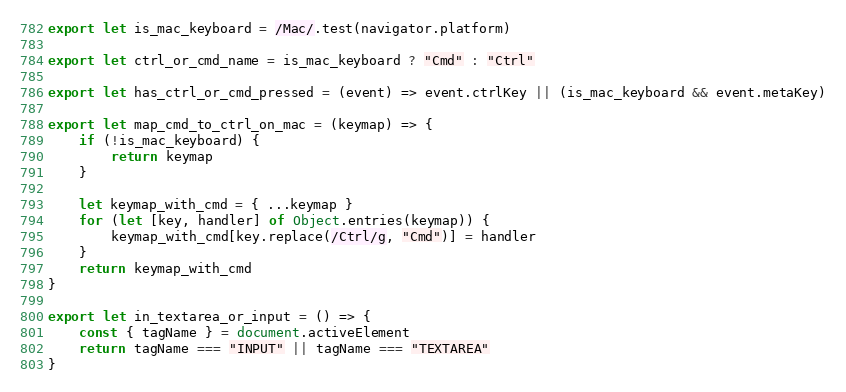Convert code to text. <code><loc_0><loc_0><loc_500><loc_500><_JavaScript_>export let is_mac_keyboard = /Mac/.test(navigator.platform)

export let ctrl_or_cmd_name = is_mac_keyboard ? "Cmd" : "Ctrl"

export let has_ctrl_or_cmd_pressed = (event) => event.ctrlKey || (is_mac_keyboard && event.metaKey)

export let map_cmd_to_ctrl_on_mac = (keymap) => {
    if (!is_mac_keyboard) {
        return keymap
    }

    let keymap_with_cmd = { ...keymap }
    for (let [key, handler] of Object.entries(keymap)) {
        keymap_with_cmd[key.replace(/Ctrl/g, "Cmd")] = handler
    }
    return keymap_with_cmd
}

export let in_textarea_or_input = () => {
    const { tagName } = document.activeElement
    return tagName === "INPUT" || tagName === "TEXTAREA"
}
</code> 